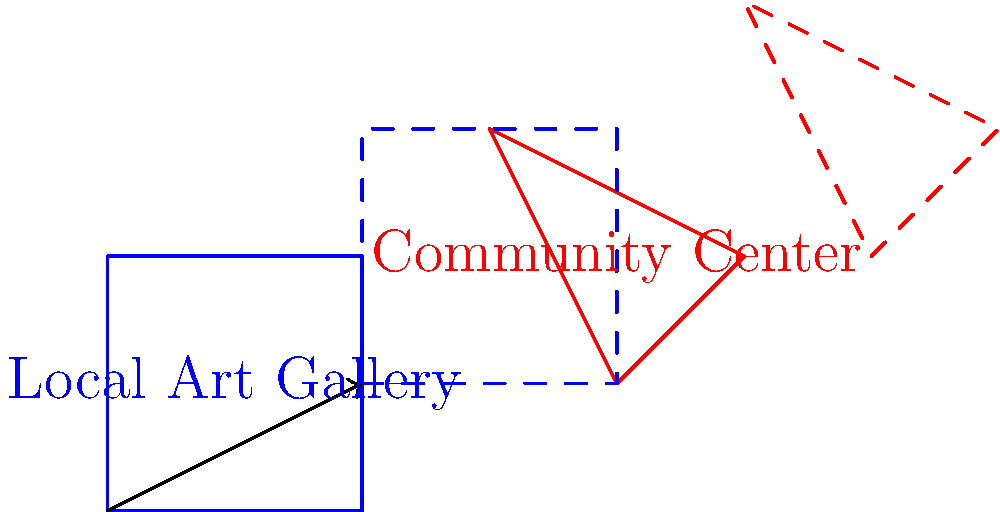In a city undergoing gentrification, two important community landmarks are represented by geometric shapes: a square (blue) for the Local Art Gallery and a triangle (red) for the Community Center. If these landmarks are translated by the vector $(2,1)$, what will be the new coordinates of the Local Art Gallery's top-right corner? To solve this problem, we'll follow these steps:

1. Identify the original coordinates of the Local Art Gallery's top-right corner:
   The square representing the Local Art Gallery has its top-right corner at $(2,2)$.

2. Understand the translation vector:
   The translation vector is $(2,1)$, which means we need to add 2 to the x-coordinate and 1 to the y-coordinate.

3. Apply the translation:
   - Original x-coordinate: 2
   - Translation in x-direction: +2
   - New x-coordinate: $2 + 2 = 4$

   - Original y-coordinate: 2
   - Translation in y-direction: +1
   - New y-coordinate: $2 + 1 = 3$

4. Combine the new coordinates:
   The new coordinates of the Local Art Gallery's top-right corner after translation are $(4,3)$.

This translation represents the displacement of local landmarks due to gentrification, highlighting the spatial changes in the community.
Answer: $(4,3)$ 